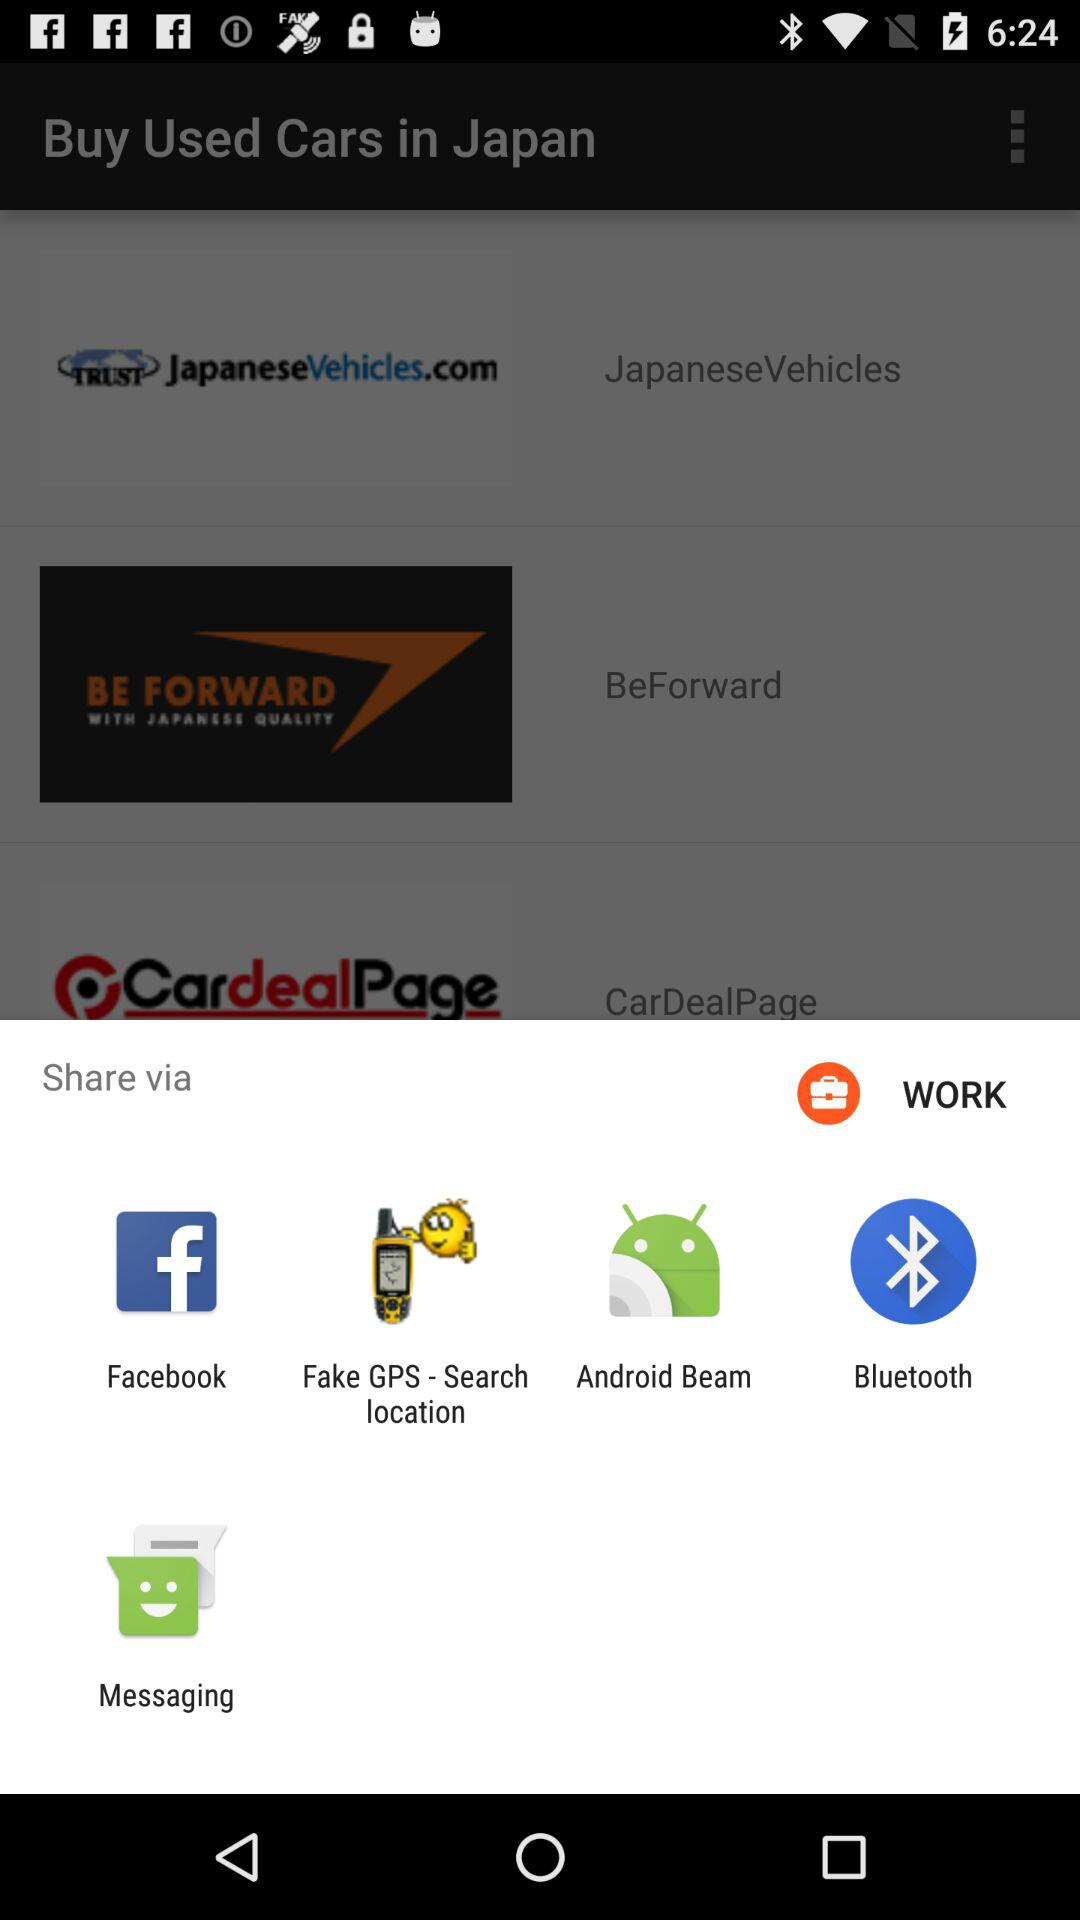What are the different sharing options? You can share it with Facebook, Fake GPS - Search location, Android Beam, Bluetooth and Messaging. 